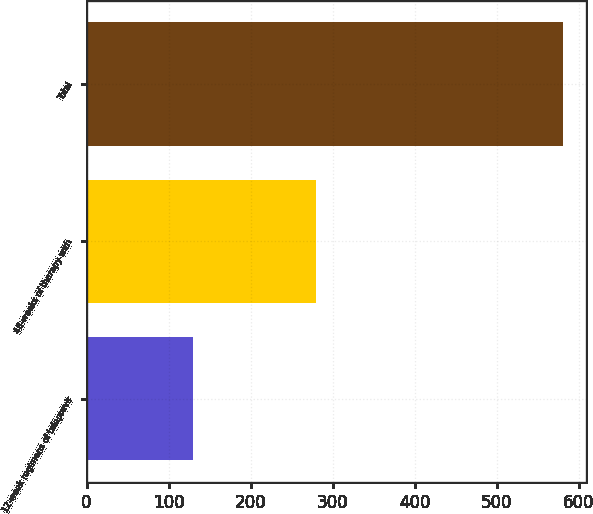<chart> <loc_0><loc_0><loc_500><loc_500><bar_chart><fcel>12-week regimens of telaprevir<fcel>48-weeks of therapy with<fcel>Total<nl><fcel>130<fcel>280<fcel>580<nl></chart> 